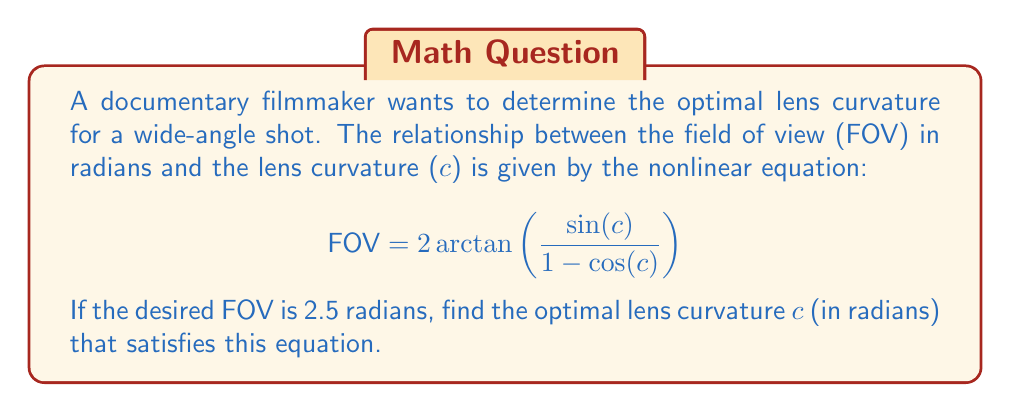Can you solve this math problem? To solve this problem, we need to use nonlinear equation solving techniques. Let's approach this step-by-step:

1) First, let's define our equation:

   $$ 2.5 = 2 \arctan\left(\frac{\sin(c)}{1 - \cos(c)}\right) $$

2) This equation cannot be solved algebraically, so we need to use numerical methods. One effective method is Newton's method.

3) Newton's method is given by the formula:

   $$ c_{n+1} = c_n - \frac{f(c_n)}{f'(c_n)} $$

   where $f(c) = 2 \arctan\left(\frac{\sin(c)}{1 - \cos(c)}\right) - 2.5$

4) We need to find $f'(c)$. Using the chain rule and derivative of arctan:

   $$ f'(c) = 2 \cdot \frac{1}{1 + \left(\frac{\sin(c)}{1 - \cos(c)}\right)^2} \cdot \frac{(1-\cos(c))\cos(c) + \sin^2(c)}{(1-\cos(c))^2} $$

5) Let's start with an initial guess of $c_0 = 1.5$ (close to $\pi/2$).

6) Applying Newton's method iteratively:

   $c_1 \approx 1.3580$
   $c_2 \approx 1.3095$
   $c_3 \approx 1.3093$
   $c_4 \approx 1.3093$

7) The value converges to approximately 1.3093 radians.

8) We can verify this by plugging it back into the original equation:

   $$ 2 \arctan\left(\frac{\sin(1.3093)}{1 - \cos(1.3093)}\right) \approx 2.5000 $$
Answer: $c \approx 1.3093$ radians 